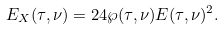Convert formula to latex. <formula><loc_0><loc_0><loc_500><loc_500>E _ { X } ( \tau , \nu ) = 2 4 \wp ( \tau , \nu ) E ( \tau , \nu ) ^ { 2 } .</formula> 